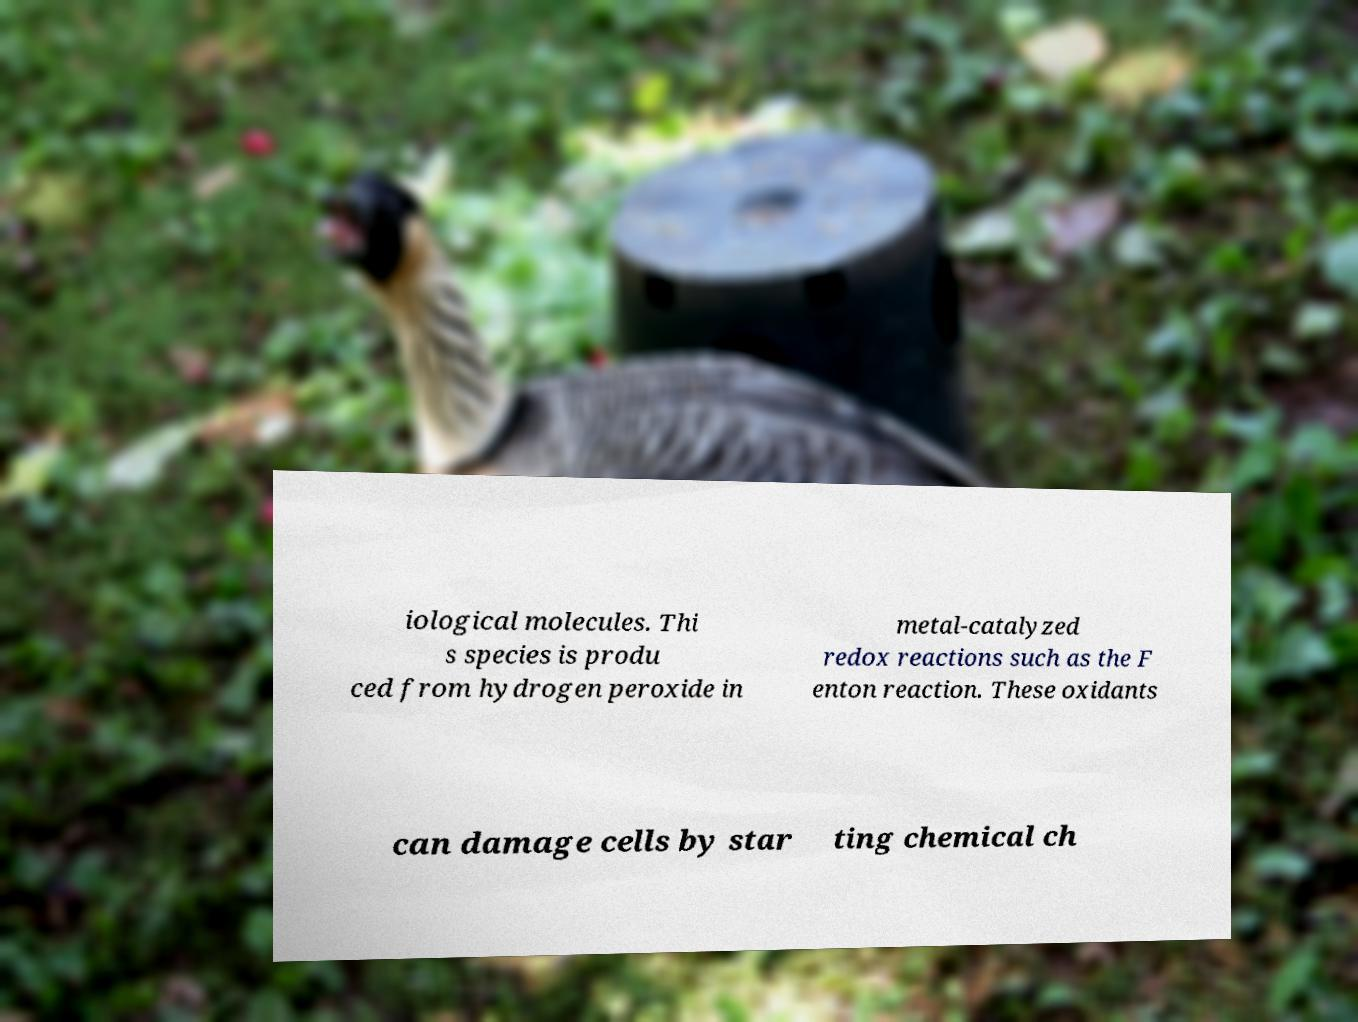Can you read and provide the text displayed in the image?This photo seems to have some interesting text. Can you extract and type it out for me? iological molecules. Thi s species is produ ced from hydrogen peroxide in metal-catalyzed redox reactions such as the F enton reaction. These oxidants can damage cells by star ting chemical ch 